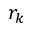<formula> <loc_0><loc_0><loc_500><loc_500>r _ { k }</formula> 